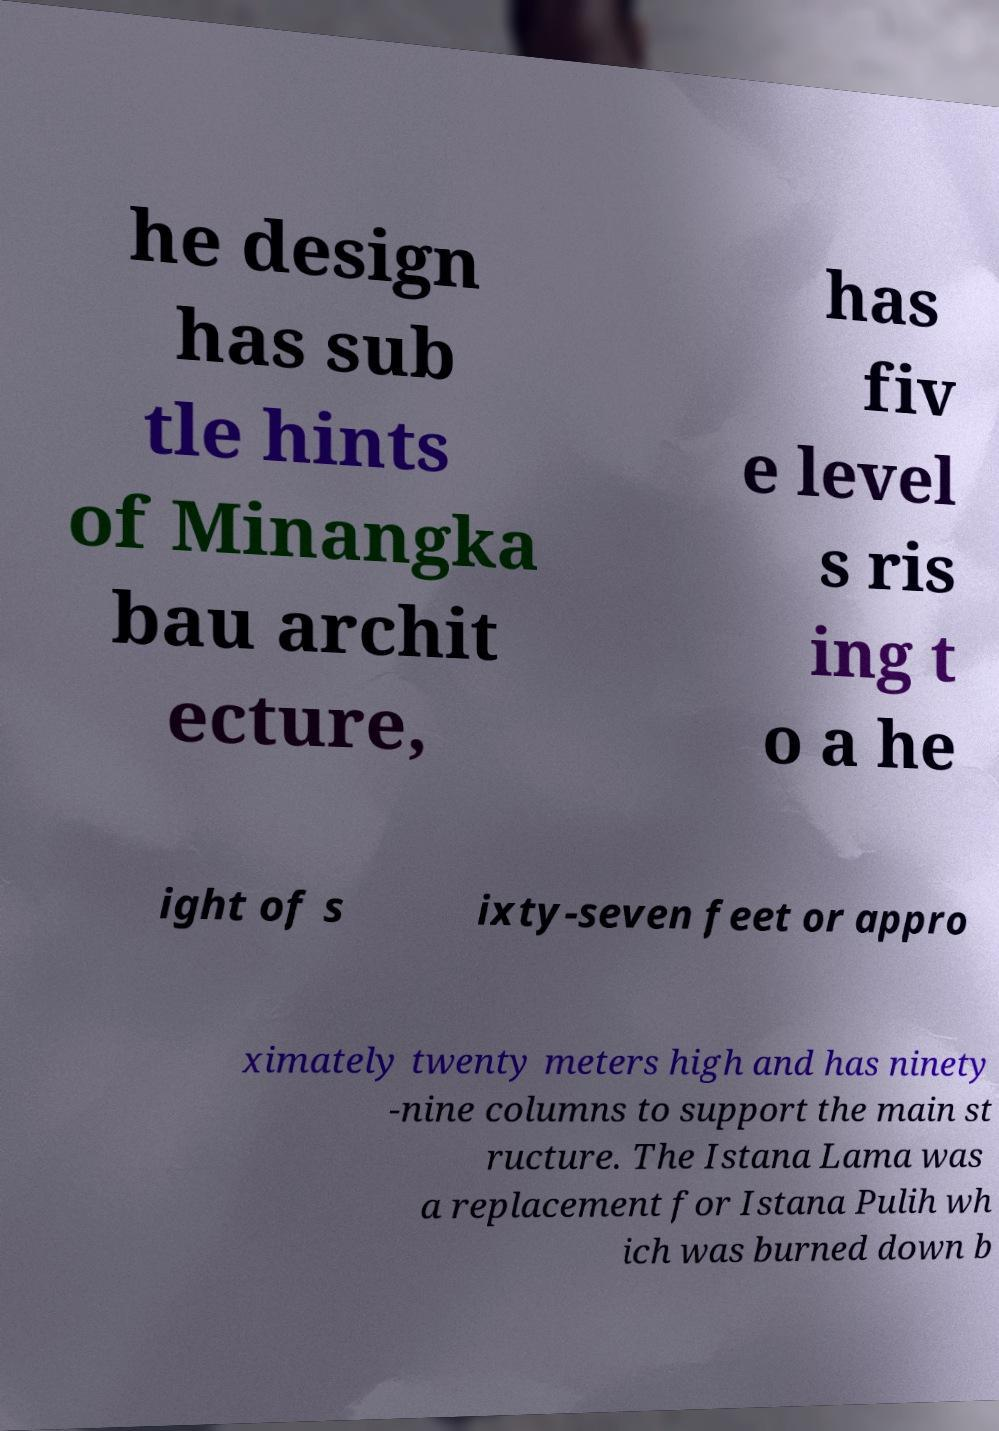Please read and relay the text visible in this image. What does it say? he design has sub tle hints of Minangka bau archit ecture, has fiv e level s ris ing t o a he ight of s ixty-seven feet or appro ximately twenty meters high and has ninety -nine columns to support the main st ructure. The Istana Lama was a replacement for Istana Pulih wh ich was burned down b 